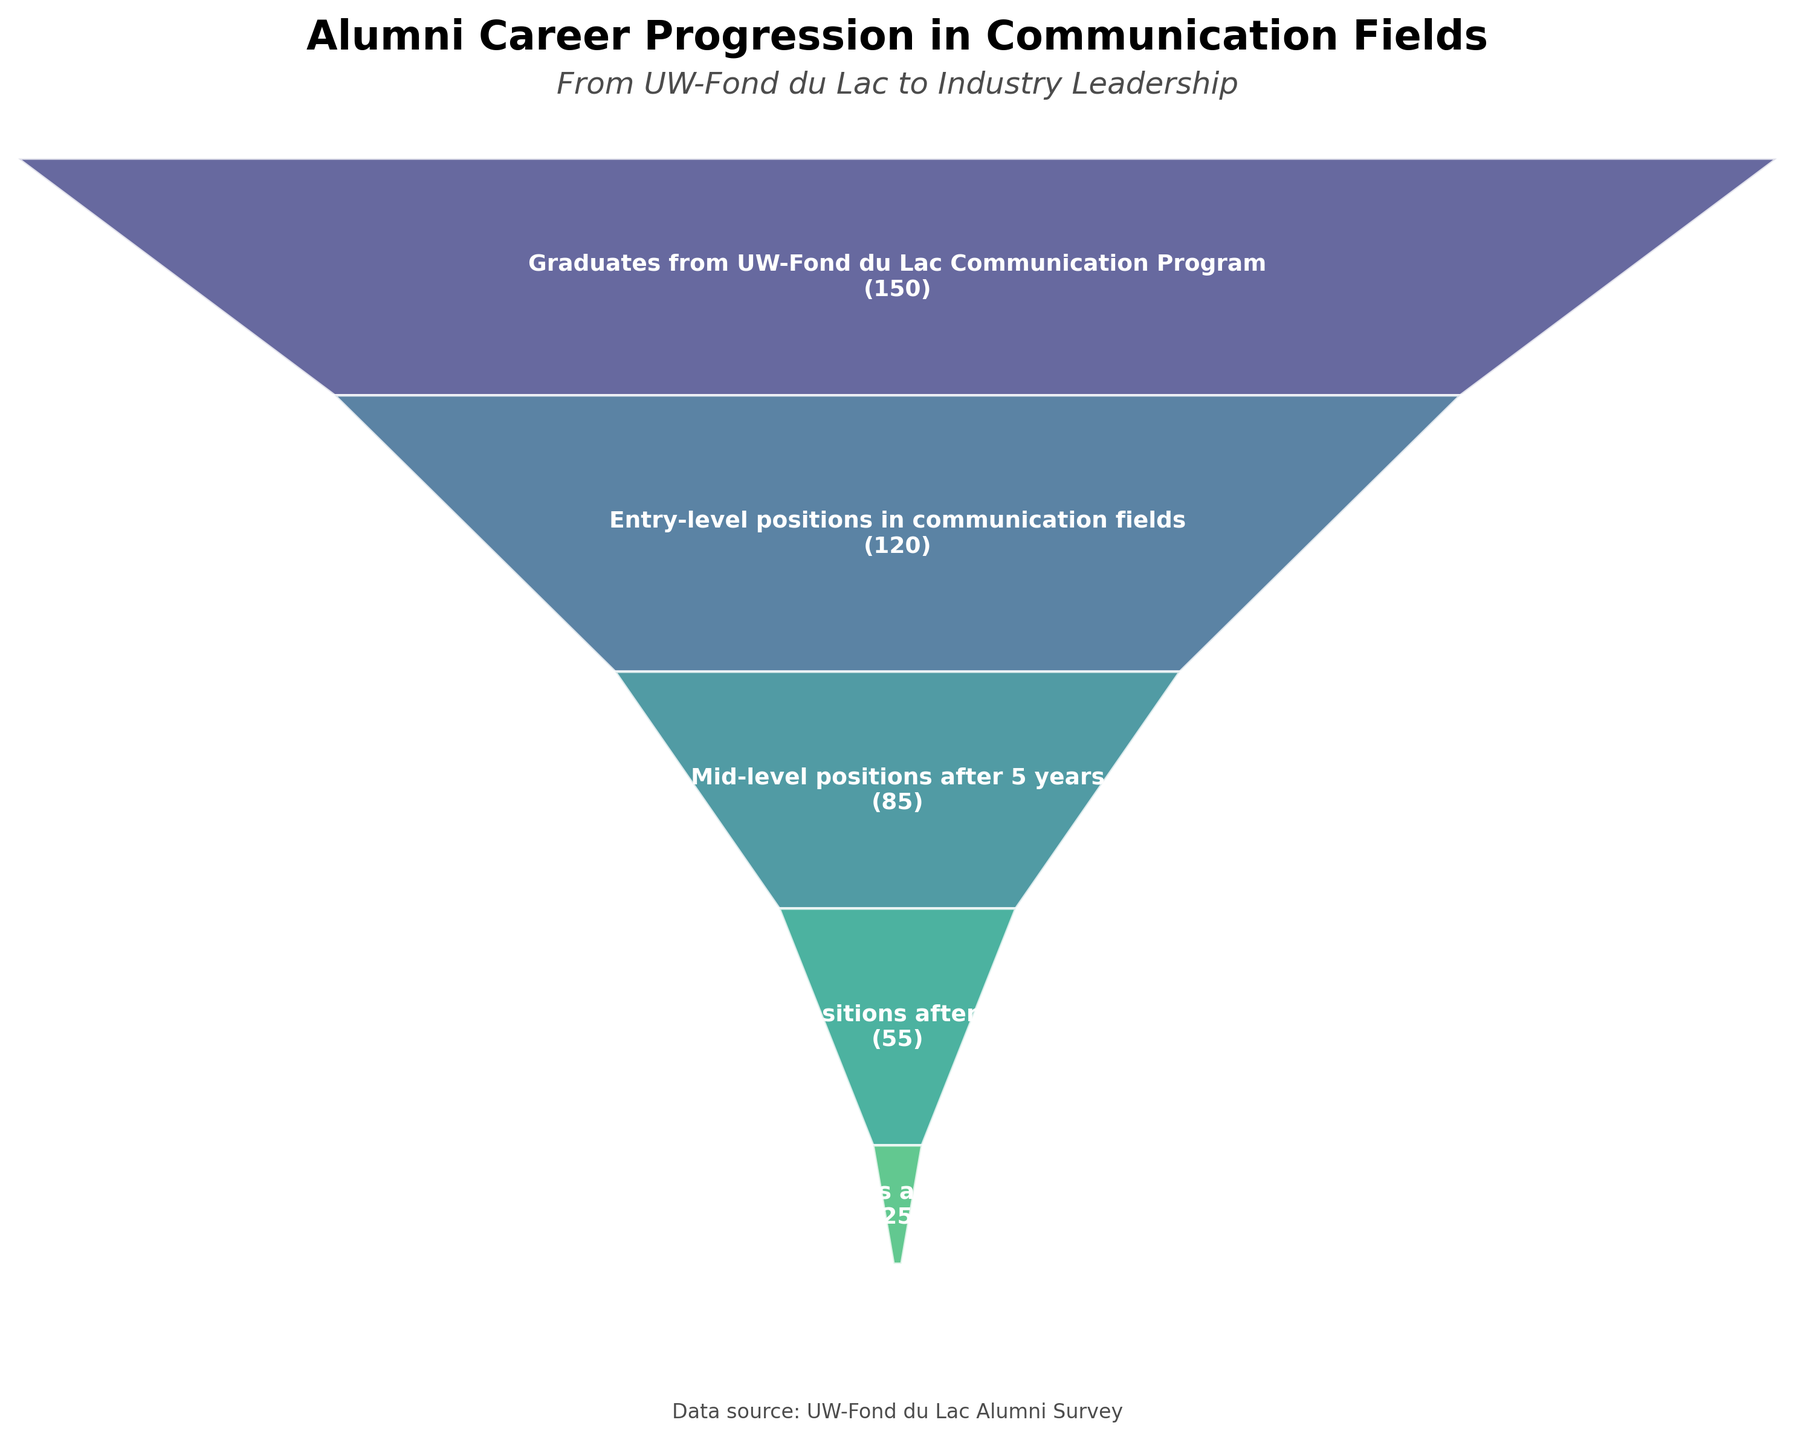What's the title of the funnel chart? The title is displayed at the top of the chart. By looking at the top, you can see the text that represents the chart’s title.
Answer: Alumni Career Progression in Communication Fields How many alumni have attained executive roles after 15+ years? The number of alumni in executive roles is shown in the funnel chart's "Executive roles after 15+ years" stage.
Answer: 25 How many stages are represented in the chart? By counting the distinct labels on each stage in the funnel chart, you can determine the number of stages.
Answer: 6 Which stage has the fewest number of alumni? By looking at the numeric values of each stage label, the stage with the smallest number is identified.
Answer: Communication department heads or consultants What is the difference in the number of alumni between mid-level positions after 5 years and senior positions after 10 years? Subtract the number of alumni in senior positions after 10 years (55) from the number in mid-level positions after 5 years (85).
Answer: 30 Which stage has a value exactly 100 alumni less than the first stage? The first stage has 150 alumni, so we find the stage with 150 - 100 = 50 alumni.
Answer: None Compare the number of alumni in entry-level positions and senior positions after 10 years. Compare the values: entry-level positions have 120 alumni, and senior positions after 10 years have 55 alumni.
Answer: Entry-level positions have more Calculate the total number of alumni from all stages combined. Sum the values from all stages: 150 + 120 + 85 + 55 + 25 + 10 = 445
Answer: 445 Is there a significant drop between any two consecutive stages, and if yes, between which stages? By examining the differences between consecutive stages’ values, identify the largest drop. The largest drop occurs between entry-level positions (120) and mid-level positions after 5 years (85).
Answer: Yes, between entry-level positions and mid-level positions after 5 years What percentage of alumni reach executive roles after 15+ years compared to those who graduate from the program? Calculate the percentage: (25 / 150) * 100
Answer: 16.67% 